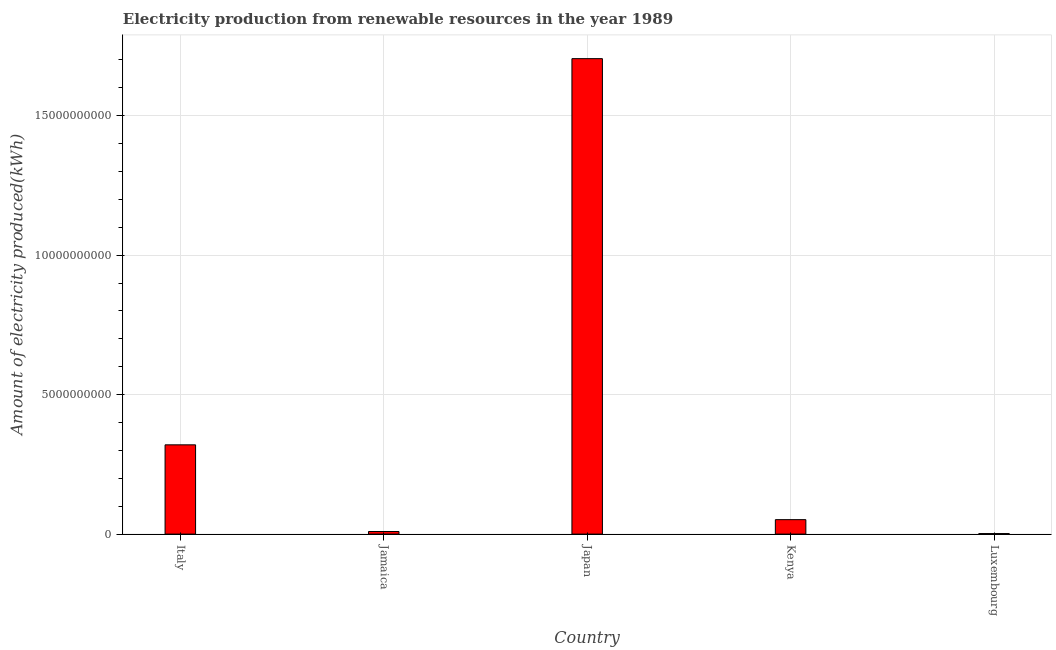Does the graph contain any zero values?
Offer a terse response. No. What is the title of the graph?
Give a very brief answer. Electricity production from renewable resources in the year 1989. What is the label or title of the X-axis?
Ensure brevity in your answer.  Country. What is the label or title of the Y-axis?
Provide a succinct answer. Amount of electricity produced(kWh). What is the amount of electricity produced in Japan?
Keep it short and to the point. 1.70e+1. Across all countries, what is the maximum amount of electricity produced?
Your response must be concise. 1.70e+1. Across all countries, what is the minimum amount of electricity produced?
Offer a very short reply. 1.90e+07. In which country was the amount of electricity produced minimum?
Make the answer very short. Luxembourg. What is the sum of the amount of electricity produced?
Your response must be concise. 2.09e+1. What is the difference between the amount of electricity produced in Jamaica and Kenya?
Provide a succinct answer. -4.25e+08. What is the average amount of electricity produced per country?
Your answer should be very brief. 4.18e+09. What is the median amount of electricity produced?
Your response must be concise. 5.18e+08. In how many countries, is the amount of electricity produced greater than 8000000000 kWh?
Make the answer very short. 1. What is the ratio of the amount of electricity produced in Italy to that in Jamaica?
Provide a short and direct response. 34.42. Is the difference between the amount of electricity produced in Jamaica and Luxembourg greater than the difference between any two countries?
Provide a short and direct response. No. What is the difference between the highest and the second highest amount of electricity produced?
Provide a short and direct response. 1.38e+1. What is the difference between the highest and the lowest amount of electricity produced?
Offer a terse response. 1.70e+1. How many bars are there?
Make the answer very short. 5. What is the Amount of electricity produced(kWh) of Italy?
Ensure brevity in your answer.  3.20e+09. What is the Amount of electricity produced(kWh) of Jamaica?
Give a very brief answer. 9.30e+07. What is the Amount of electricity produced(kWh) of Japan?
Your answer should be compact. 1.70e+1. What is the Amount of electricity produced(kWh) in Kenya?
Make the answer very short. 5.18e+08. What is the Amount of electricity produced(kWh) of Luxembourg?
Your response must be concise. 1.90e+07. What is the difference between the Amount of electricity produced(kWh) in Italy and Jamaica?
Your answer should be compact. 3.11e+09. What is the difference between the Amount of electricity produced(kWh) in Italy and Japan?
Offer a terse response. -1.38e+1. What is the difference between the Amount of electricity produced(kWh) in Italy and Kenya?
Keep it short and to the point. 2.68e+09. What is the difference between the Amount of electricity produced(kWh) in Italy and Luxembourg?
Keep it short and to the point. 3.18e+09. What is the difference between the Amount of electricity produced(kWh) in Jamaica and Japan?
Keep it short and to the point. -1.70e+1. What is the difference between the Amount of electricity produced(kWh) in Jamaica and Kenya?
Provide a short and direct response. -4.25e+08. What is the difference between the Amount of electricity produced(kWh) in Jamaica and Luxembourg?
Provide a short and direct response. 7.40e+07. What is the difference between the Amount of electricity produced(kWh) in Japan and Kenya?
Ensure brevity in your answer.  1.65e+1. What is the difference between the Amount of electricity produced(kWh) in Japan and Luxembourg?
Give a very brief answer. 1.70e+1. What is the difference between the Amount of electricity produced(kWh) in Kenya and Luxembourg?
Your answer should be compact. 4.99e+08. What is the ratio of the Amount of electricity produced(kWh) in Italy to that in Jamaica?
Provide a short and direct response. 34.42. What is the ratio of the Amount of electricity produced(kWh) in Italy to that in Japan?
Ensure brevity in your answer.  0.19. What is the ratio of the Amount of electricity produced(kWh) in Italy to that in Kenya?
Your answer should be compact. 6.18. What is the ratio of the Amount of electricity produced(kWh) in Italy to that in Luxembourg?
Ensure brevity in your answer.  168.47. What is the ratio of the Amount of electricity produced(kWh) in Jamaica to that in Japan?
Your response must be concise. 0.01. What is the ratio of the Amount of electricity produced(kWh) in Jamaica to that in Kenya?
Your answer should be very brief. 0.18. What is the ratio of the Amount of electricity produced(kWh) in Jamaica to that in Luxembourg?
Keep it short and to the point. 4.89. What is the ratio of the Amount of electricity produced(kWh) in Japan to that in Kenya?
Your answer should be compact. 32.91. What is the ratio of the Amount of electricity produced(kWh) in Japan to that in Luxembourg?
Keep it short and to the point. 897.26. What is the ratio of the Amount of electricity produced(kWh) in Kenya to that in Luxembourg?
Your response must be concise. 27.26. 